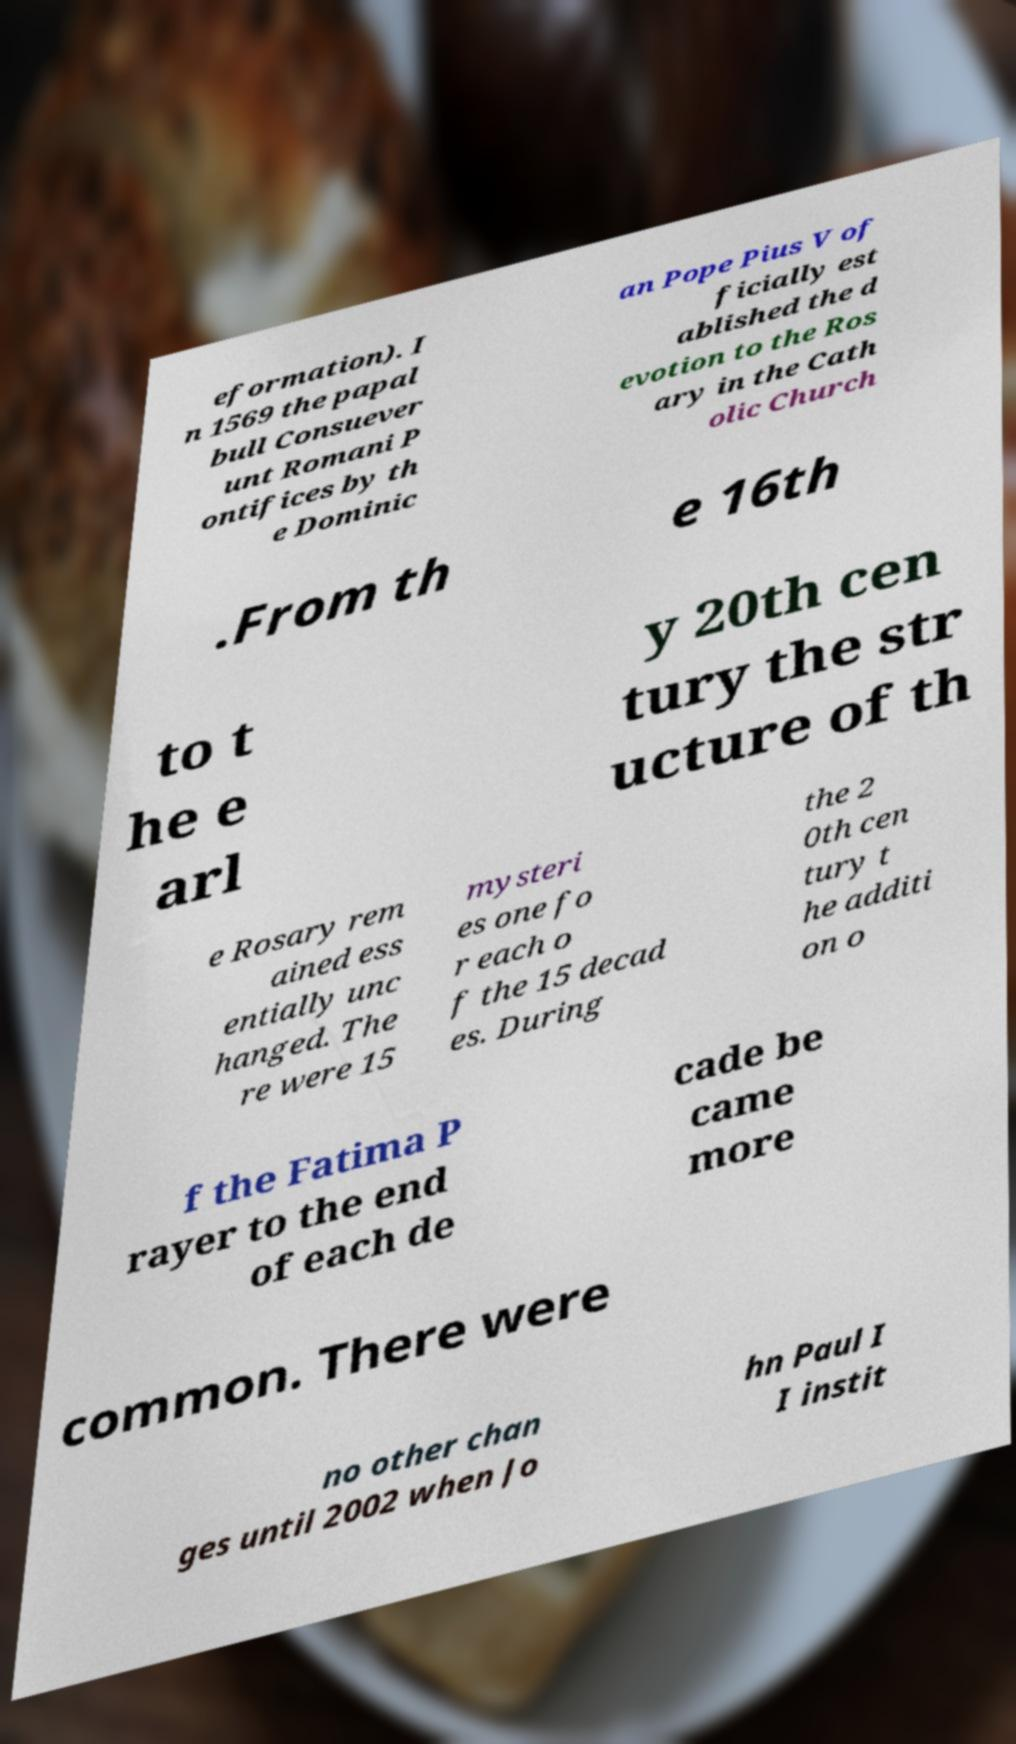Please read and relay the text visible in this image. What does it say? eformation). I n 1569 the papal bull Consuever unt Romani P ontifices by th e Dominic an Pope Pius V of ficially est ablished the d evotion to the Ros ary in the Cath olic Church .From th e 16th to t he e arl y 20th cen tury the str ucture of th e Rosary rem ained ess entially unc hanged. The re were 15 mysteri es one fo r each o f the 15 decad es. During the 2 0th cen tury t he additi on o f the Fatima P rayer to the end of each de cade be came more common. There were no other chan ges until 2002 when Jo hn Paul I I instit 